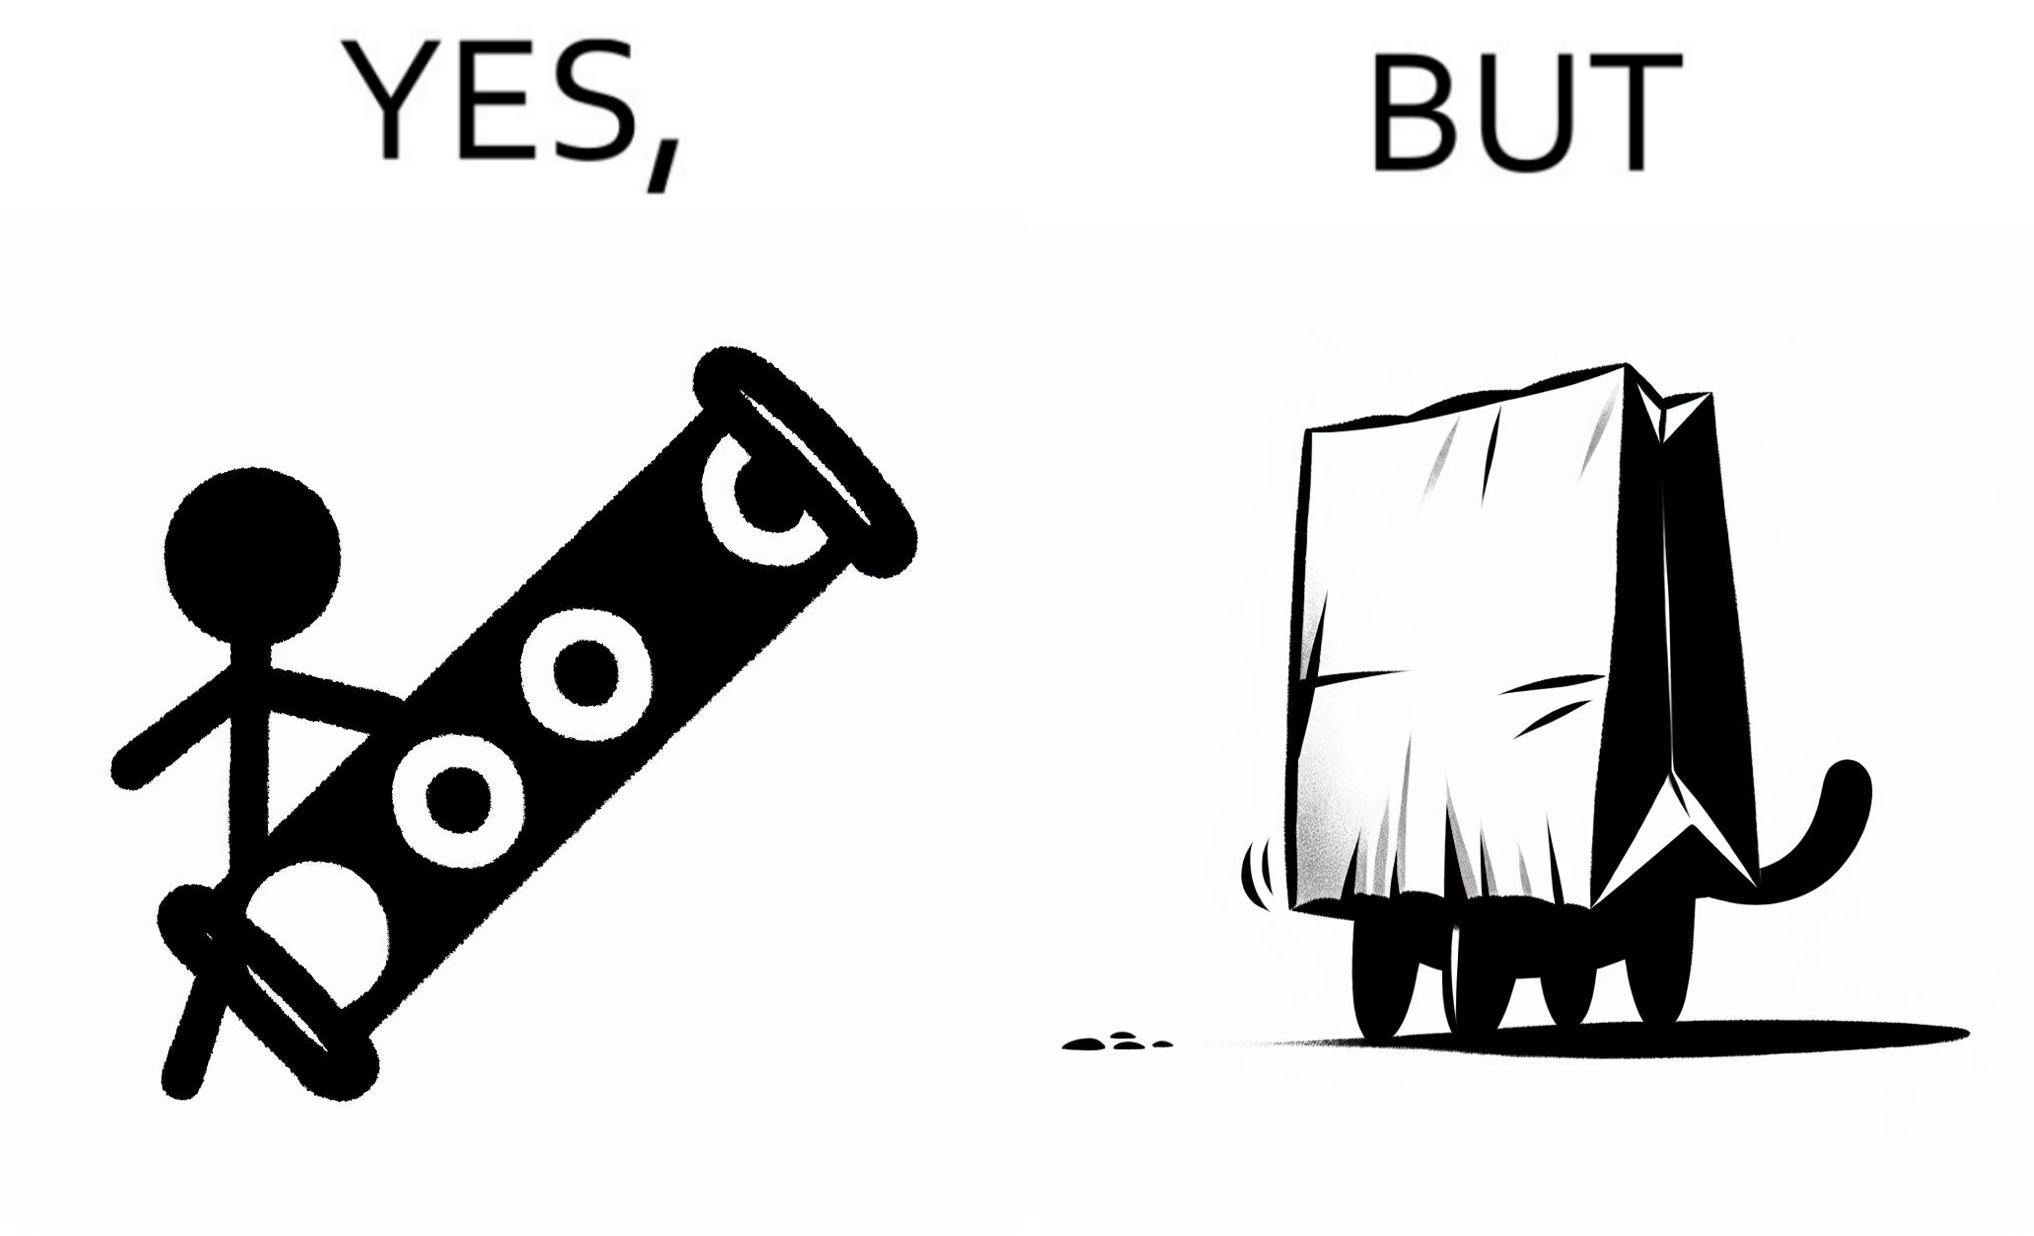Is there satirical content in this image? Yes, this image is satirical. 